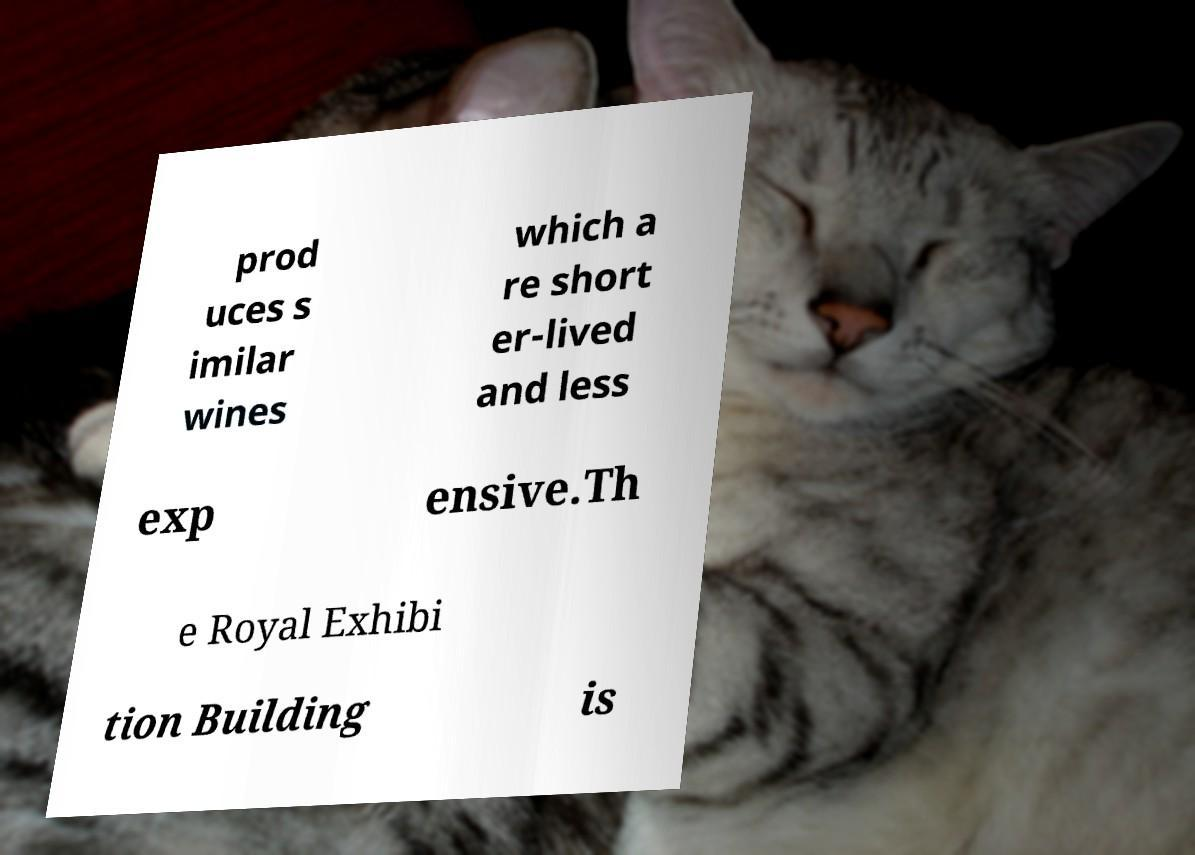For documentation purposes, I need the text within this image transcribed. Could you provide that? prod uces s imilar wines which a re short er-lived and less exp ensive.Th e Royal Exhibi tion Building is 